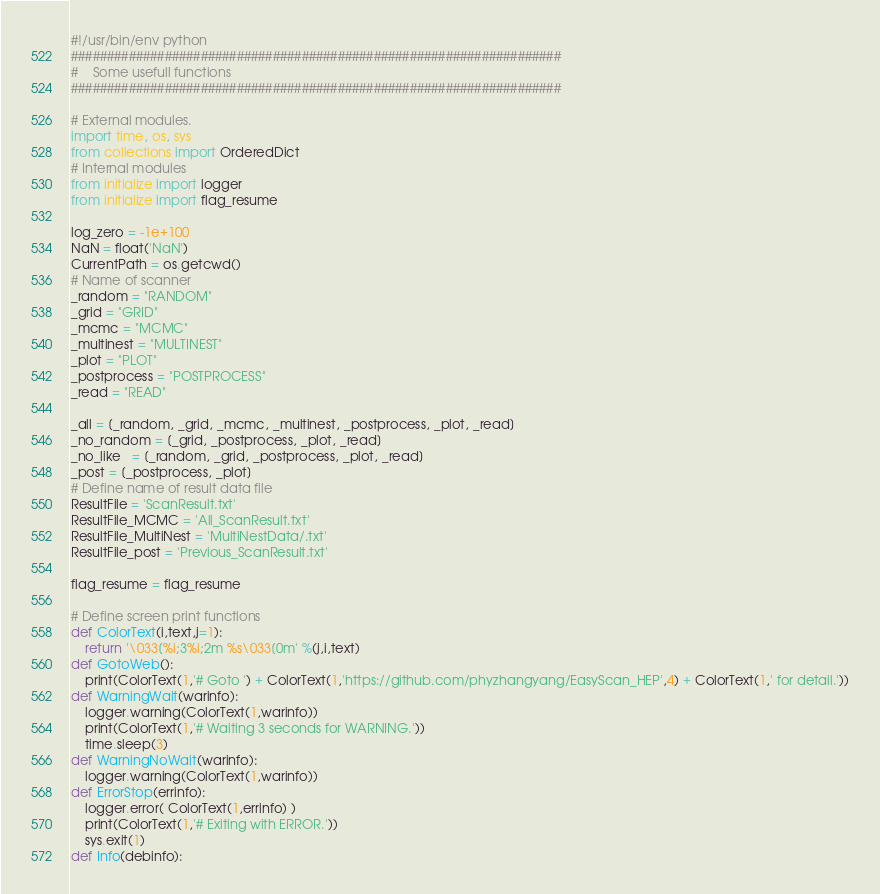Convert code to text. <code><loc_0><loc_0><loc_500><loc_500><_Python_>#!/usr/bin/env python
####################################################################
#    Some usefull functions
####################################################################

# External modules.
import time, os, sys
from collections import OrderedDict
# Internal modules
from initialize import logger
from initialize import flag_resume

log_zero = -1e+100
NaN = float('NaN')
CurrentPath = os.getcwd()
# Name of scanner
_random = "RANDOM"
_grid = "GRID"
_mcmc = "MCMC"
_multinest = "MULTINEST"
_plot = "PLOT"
_postprocess = "POSTPROCESS"
_read = "READ"

_all = [_random, _grid, _mcmc, _multinest, _postprocess, _plot, _read]
_no_random = [_grid, _postprocess, _plot, _read]
_no_like   = [_random, _grid, _postprocess, _plot, _read]
_post = [_postprocess, _plot]
# Define name of result data file
ResultFile = 'ScanResult.txt'
ResultFile_MCMC = 'All_ScanResult.txt'
ResultFile_MultiNest = 'MultiNestData/.txt'
ResultFile_post = 'Previous_ScanResult.txt'

flag_resume = flag_resume

# Define screen print functions
def ColorText(i,text,j=1):
    return '\033[%i;3%i;2m %s\033[0m' %(j,i,text)
def GotoWeb():
    print(ColorText(1,'# Goto ') + ColorText(1,'https://github.com/phyzhangyang/EasyScan_HEP',4) + ColorText(1,' for detail.'))
def WarningWait(warinfo):
    logger.warning(ColorText(1,warinfo))
    print(ColorText(1,'# Waiting 3 seconds for WARNING.'))
    time.sleep(3)
def WarningNoWait(warinfo):
    logger.warning(ColorText(1,warinfo))
def ErrorStop(errinfo):
    logger.error( ColorText(1,errinfo) )
    print(ColorText(1,'# Exiting with ERROR.'))
    sys.exit(1)
def Info(debinfo):</code> 